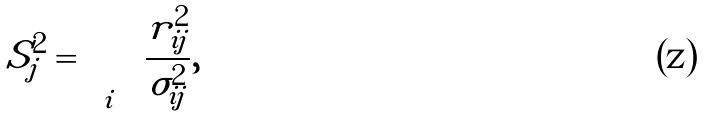Convert formula to latex. <formula><loc_0><loc_0><loc_500><loc_500>S _ { j } ^ { 2 } = \sum _ { i } \frac { r _ { i j } ^ { 2 } } { \sigma ^ { 2 } _ { i j } } ,</formula> 